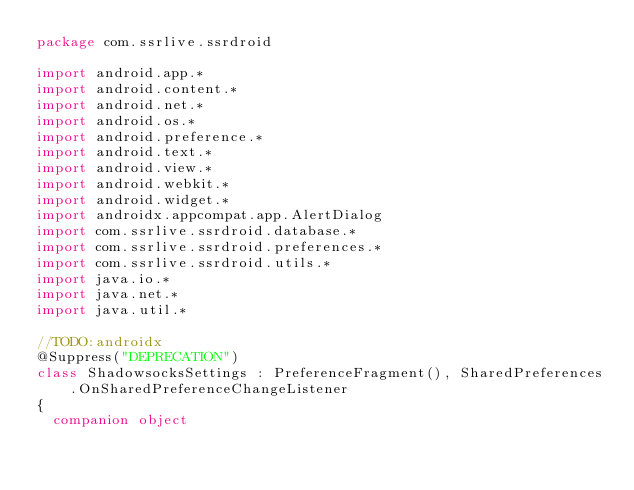<code> <loc_0><loc_0><loc_500><loc_500><_Kotlin_>package com.ssrlive.ssrdroid

import android.app.*
import android.content.*
import android.net.*
import android.os.*
import android.preference.*
import android.text.*
import android.view.*
import android.webkit.*
import android.widget.*
import androidx.appcompat.app.AlertDialog
import com.ssrlive.ssrdroid.database.*
import com.ssrlive.ssrdroid.preferences.*
import com.ssrlive.ssrdroid.utils.*
import java.io.*
import java.net.*
import java.util.*

//TODO:androidx
@Suppress("DEPRECATION")
class ShadowsocksSettings : PreferenceFragment(), SharedPreferences.OnSharedPreferenceChangeListener
{
	companion object</code> 